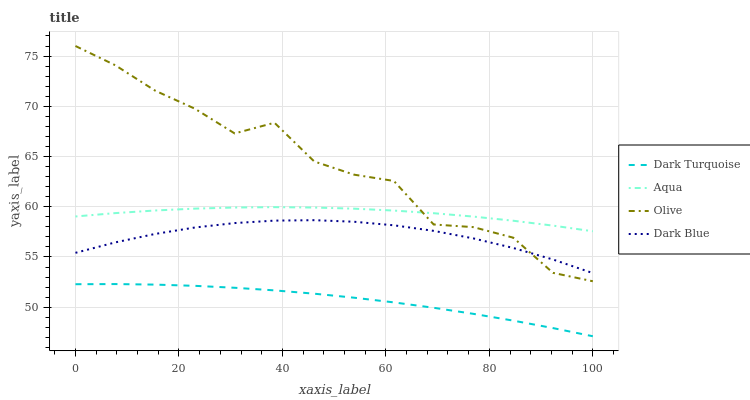Does Dark Turquoise have the minimum area under the curve?
Answer yes or no. Yes. Does Olive have the maximum area under the curve?
Answer yes or no. Yes. Does Aqua have the minimum area under the curve?
Answer yes or no. No. Does Aqua have the maximum area under the curve?
Answer yes or no. No. Is Dark Turquoise the smoothest?
Answer yes or no. Yes. Is Olive the roughest?
Answer yes or no. Yes. Is Aqua the smoothest?
Answer yes or no. No. Is Aqua the roughest?
Answer yes or no. No. Does Dark Turquoise have the lowest value?
Answer yes or no. Yes. Does Aqua have the lowest value?
Answer yes or no. No. Does Olive have the highest value?
Answer yes or no. Yes. Does Aqua have the highest value?
Answer yes or no. No. Is Dark Turquoise less than Olive?
Answer yes or no. Yes. Is Olive greater than Dark Turquoise?
Answer yes or no. Yes. Does Olive intersect Aqua?
Answer yes or no. Yes. Is Olive less than Aqua?
Answer yes or no. No. Is Olive greater than Aqua?
Answer yes or no. No. Does Dark Turquoise intersect Olive?
Answer yes or no. No. 